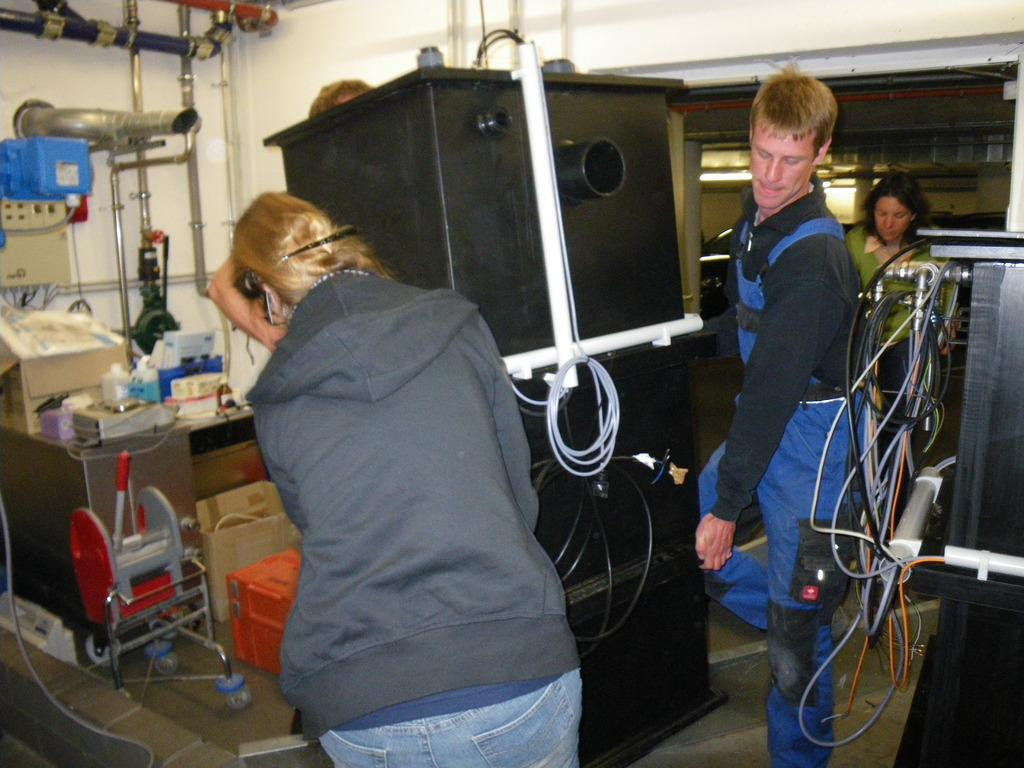How many people are present in the image? There are two people, a man and a woman, present in the image. What are the man and woman doing in the image? The man and woman are holding a large box. Are there any other people in the image besides the man and woman? Yes, there are women standing in the image. What else can be seen in the image besides the people? There are boxes on a table and boxes on the floor in the image. What type of jelly can be seen in the image? There is no jelly present in the image. --- Facts: 1. There is a car in the image. 2. The car is red. 3. There are people standing near the car. 4. The car has four wheels. 5. The car has a sunroof. Absurd Topics: unicorn, rainbow, stars Conversation: What type of vehicle is in the image? There is a car in the image. What color is the car? The car is red. What can be seen near the car? There are people standing near the car. How many wheels does the car have? The car has four wheels. What special feature does the car have? The car has a sunroof. Reasoning: Let's think step by step in order to produce the conversation. We start by identifying the main subject in the image, which is the car. Next, we describe specific features of the car, such as its color and the presence of a sunroof. Then, we observe the actions of the people in the image, noting that they are standing near the car. Finally, we describe the other objects present in the image, which are the wheels of the car. Absurd Question/Answer: Can you see a unicorn in the image? There is no unicorn present in the image. --- Facts: 1. There is a dog in the image. 2. The dog is brown. 3. The dog is wagging its tail. 4. The dog is sitting. 5. The dog has a collar. Absurd Topics: lion, tiger Conversation: What type of animal is in the image? There is a dog in the image. What color is the dog? The dog is brown. What is the dog doing in the image? The dog is wagging its tail and sitting. What can be seen around the dog's neck in the image? The dog has a collar. Reasoning: Let's think step by step in order to produce the conversation. We start by identifying the main subject in the image, which is the dog. Next, we describe specific features of the dog, such as its color and the presence of a collar around its neck. Then, we observe the actions of the dog 